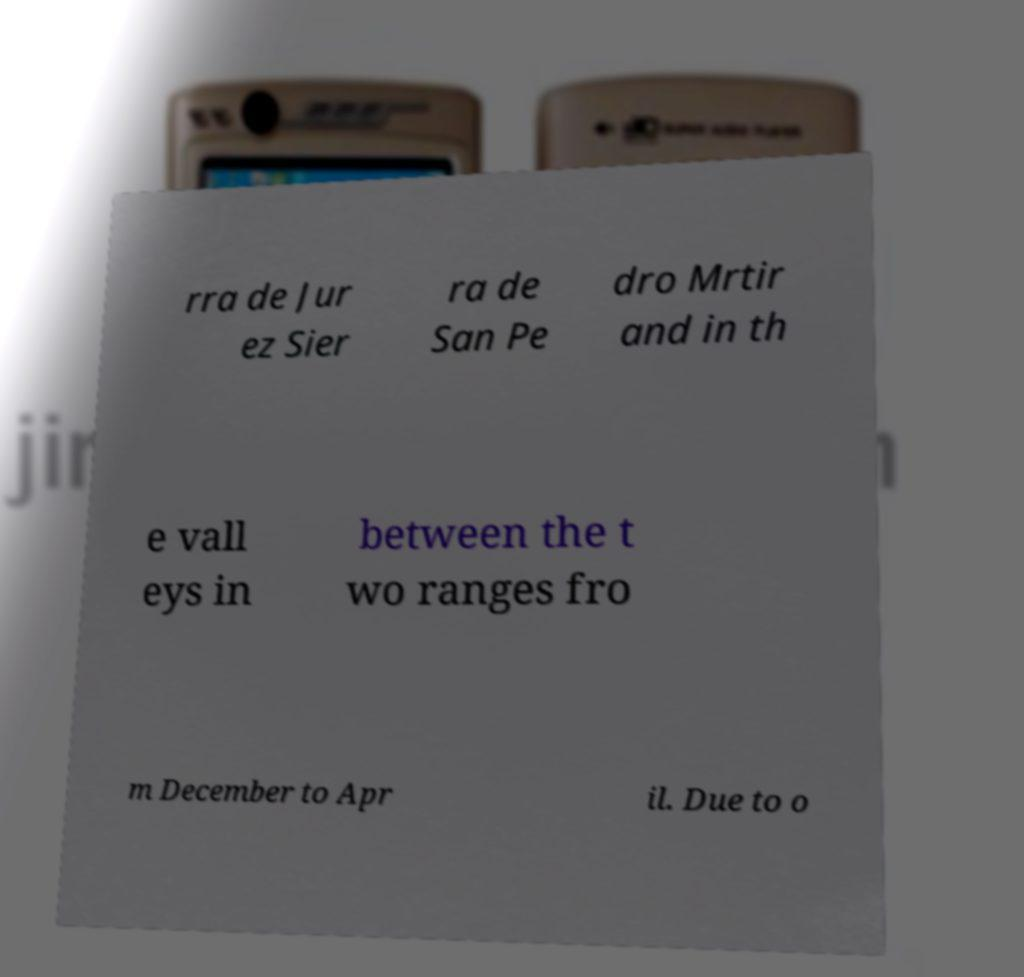There's text embedded in this image that I need extracted. Can you transcribe it verbatim? rra de Jur ez Sier ra de San Pe dro Mrtir and in th e vall eys in between the t wo ranges fro m December to Apr il. Due to o 